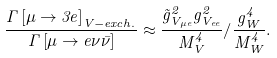<formula> <loc_0><loc_0><loc_500><loc_500>\frac { \Gamma \left [ \mu \rightarrow 3 e \right ] _ { V - e x c h . } } { \Gamma \left [ \mu \rightarrow e \nu \bar { \nu } \right ] } \approx \frac { \tilde { g } _ { V _ { \mu e } } ^ { 2 } g _ { V _ { e e } } ^ { 2 } } { M _ { V } ^ { 4 } } / \frac { g _ { W } ^ { 4 } } { M _ { W } ^ { 4 } } .</formula> 